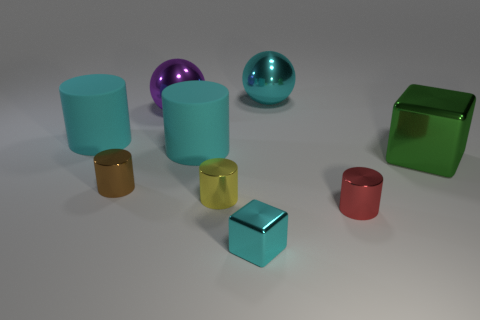Subtract all tiny yellow cylinders. How many cylinders are left? 4 Add 1 gray rubber spheres. How many objects exist? 10 Subtract all purple spheres. How many spheres are left? 1 Subtract all spheres. How many objects are left? 7 Subtract 3 cylinders. How many cylinders are left? 2 Subtract all blue spheres. Subtract all green cubes. How many spheres are left? 2 Subtract all green spheres. How many cyan cylinders are left? 2 Subtract all brown matte objects. Subtract all red cylinders. How many objects are left? 8 Add 6 green things. How many green things are left? 7 Add 2 large green blocks. How many large green blocks exist? 3 